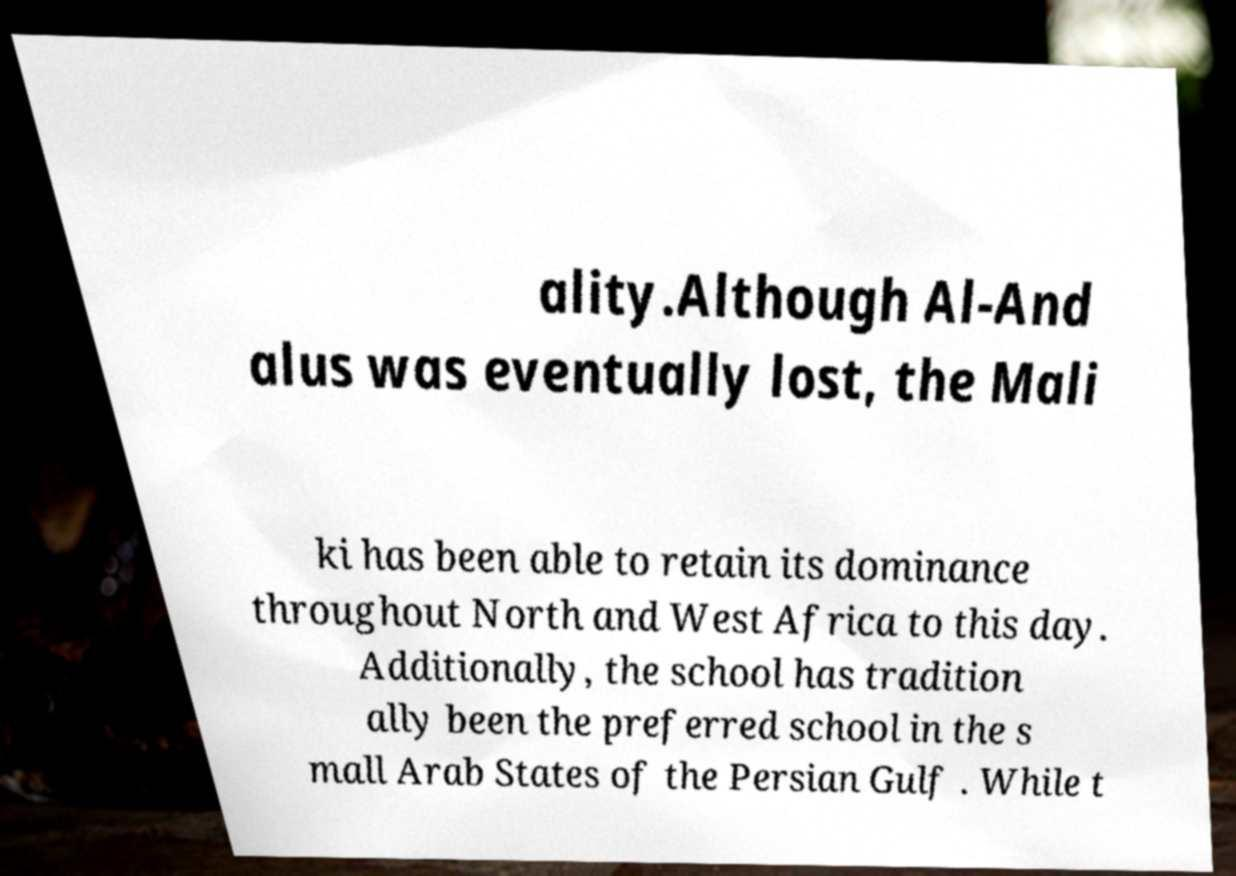I need the written content from this picture converted into text. Can you do that? ality.Although Al-And alus was eventually lost, the Mali ki has been able to retain its dominance throughout North and West Africa to this day. Additionally, the school has tradition ally been the preferred school in the s mall Arab States of the Persian Gulf . While t 